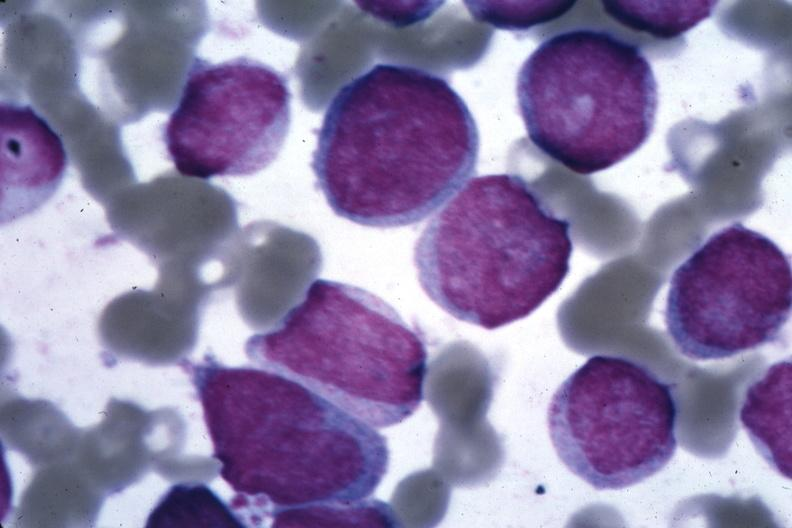what is present?
Answer the question using a single word or phrase. Acute myelogenous leukemia 